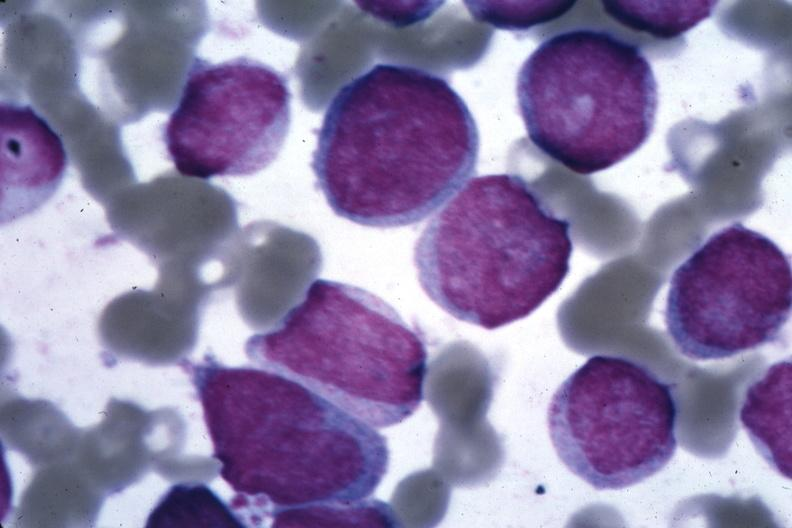what is present?
Answer the question using a single word or phrase. Acute myelogenous leukemia 